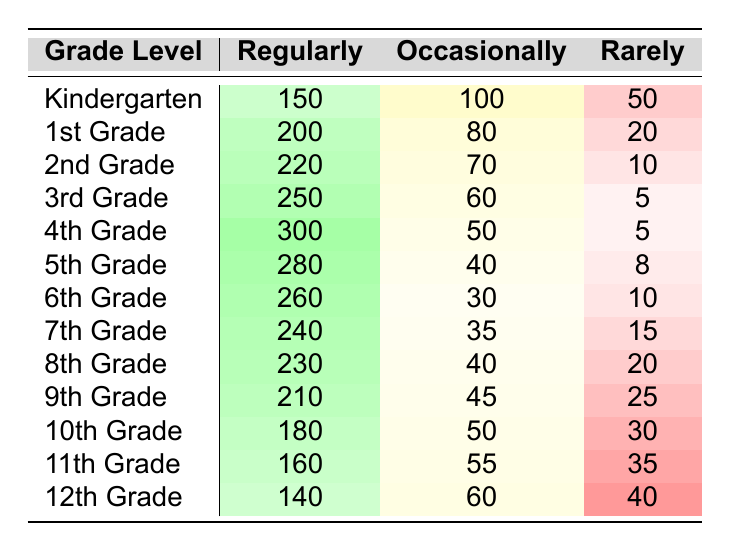What is the frequency of online learning platform usage for 4th Grade students regularly? From the table, I can see that for 4th Grade, the number of students using the platform regularly is 300.
Answer: 300 Which grade has the lowest frequency of usage occasionally? Looking at the occasional usage column, I can see that 5th Grade has the lowest frequency with 40 students.
Answer: 40 What is the total frequency of usage for 2nd Grade students? To find the total for 2nd Grade, I need to add all three categories: Regularly (220) + Occasionally (70) + Rarely (10) = 300.
Answer: 300 Is there a higher frequency of usage regularly or occasionally for 6th Grade? In the table, 6th Grade has 260 students using a platform regularly and 30 occasionally. Since 260 is greater than 30, the answer is regularly.
Answer: Yes, regularly What is the difference in usage between Regularly and Rarely for 9th Grade? I find the usage numbers for 9th Grade: Regularly is 210 and Rarely is 25. The difference is 210 - 25 = 185.
Answer: 185 Which grade level has the highest total frequency of usage? I will find the totals for each grade by summing Regularly, Occasionally, and Rarely. For 4th Grade, it's 300 + 50 + 5 = 355, for 5th Grade it's 280 + 40 + 8 = 328, and so forth. The highest total comes from 4th Grade with 355.
Answer: 4th Grade What percentage of 3rd Grade students use the platform occasionally? To get the percentage, I need to find the total number of 3rd Grade users: Regularly (250) + Occasionally (60) + Rarely (5) = 315. Then, for occasionally which is 60, the percentage is (60/315) * 100 = 19.05%, which rounds to 19%.
Answer: 19% How many grades have more than 200 students using the online platform occasionally? I will look through the Occasionally column: Only 1st Grade (80), 2nd Grade (70), and 3rd Grade (60) fall below 200. 7th Grade has 35, 8th Grade has 40. This means all grades, except Kindergarten to 6th Grade, are below 200 in occasional usage. The count of grades above is zero.
Answer: None What is the average frequency of usage regularly for all grades combined? To find the average, I will sum all the Regularly frequencies: 150 + 200 + 220 + 250 + 300 + 280 + 260 + 240 + 230 + 210 + 180 + 160 + 140 = 2,630. There are 13 grades, so the average is 2630 / 13 ≈ 202.3 rounded to 202.
Answer: 202 